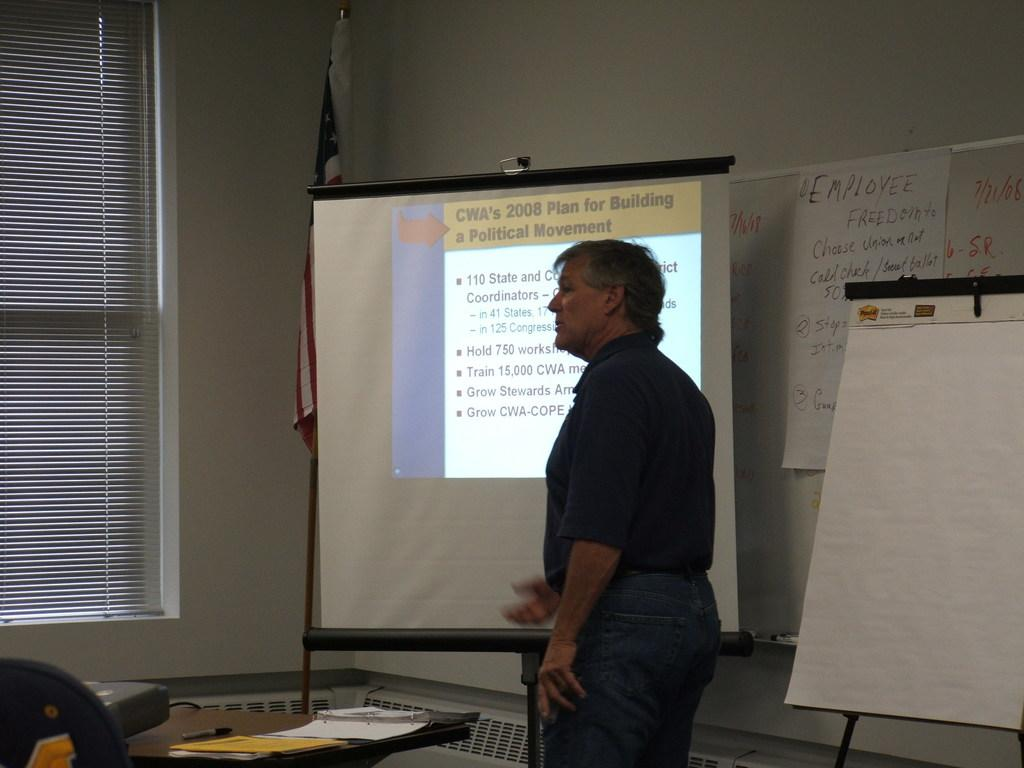<image>
Summarize the visual content of the image. A building plan for 2008 is shown on a screen. 